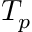<formula> <loc_0><loc_0><loc_500><loc_500>T _ { p }</formula> 